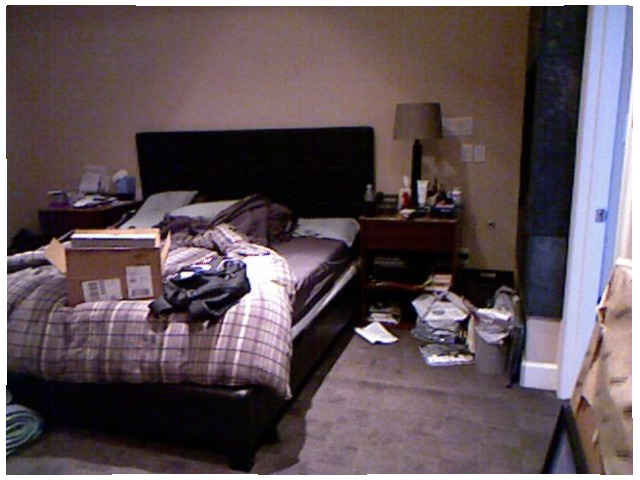<image>
Is there a bed under the box? Yes. The bed is positioned underneath the box, with the box above it in the vertical space. Is the table lamp on the table? Yes. Looking at the image, I can see the table lamp is positioned on top of the table, with the table providing support. Is the box on the bed? Yes. Looking at the image, I can see the box is positioned on top of the bed, with the bed providing support. Where is the box in relation to the blanket? Is it on the blanket? Yes. Looking at the image, I can see the box is positioned on top of the blanket, with the blanket providing support. Is the box on the floor? No. The box is not positioned on the floor. They may be near each other, but the box is not supported by or resting on top of the floor. Where is the book in relation to the table? Is it on the table? No. The book is not positioned on the table. They may be near each other, but the book is not supported by or resting on top of the table. Is the box next to the bed? No. The box is not positioned next to the bed. They are located in different areas of the scene. 